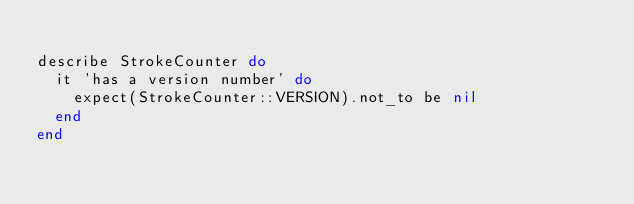<code> <loc_0><loc_0><loc_500><loc_500><_Ruby_>
describe StrokeCounter do
  it 'has a version number' do
    expect(StrokeCounter::VERSION).not_to be nil
  end
end
</code> 